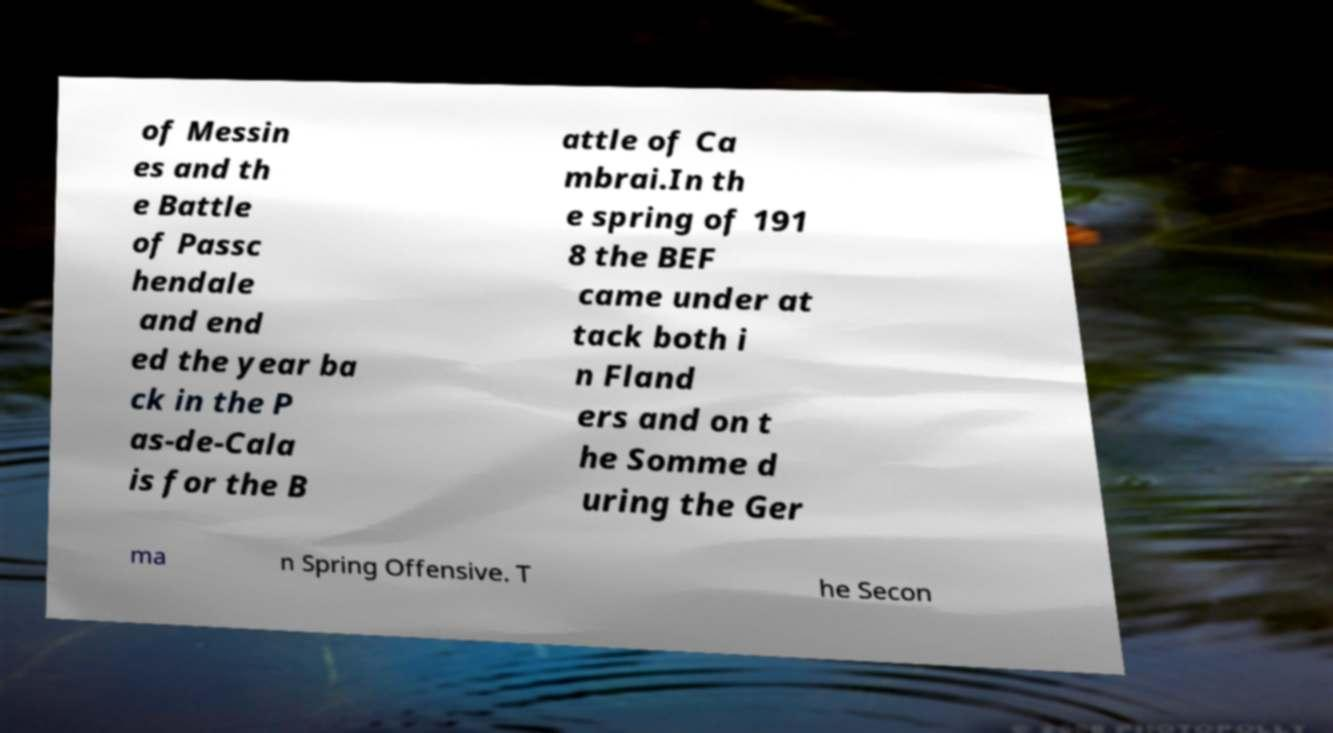Could you assist in decoding the text presented in this image and type it out clearly? of Messin es and th e Battle of Passc hendale and end ed the year ba ck in the P as-de-Cala is for the B attle of Ca mbrai.In th e spring of 191 8 the BEF came under at tack both i n Fland ers and on t he Somme d uring the Ger ma n Spring Offensive. T he Secon 